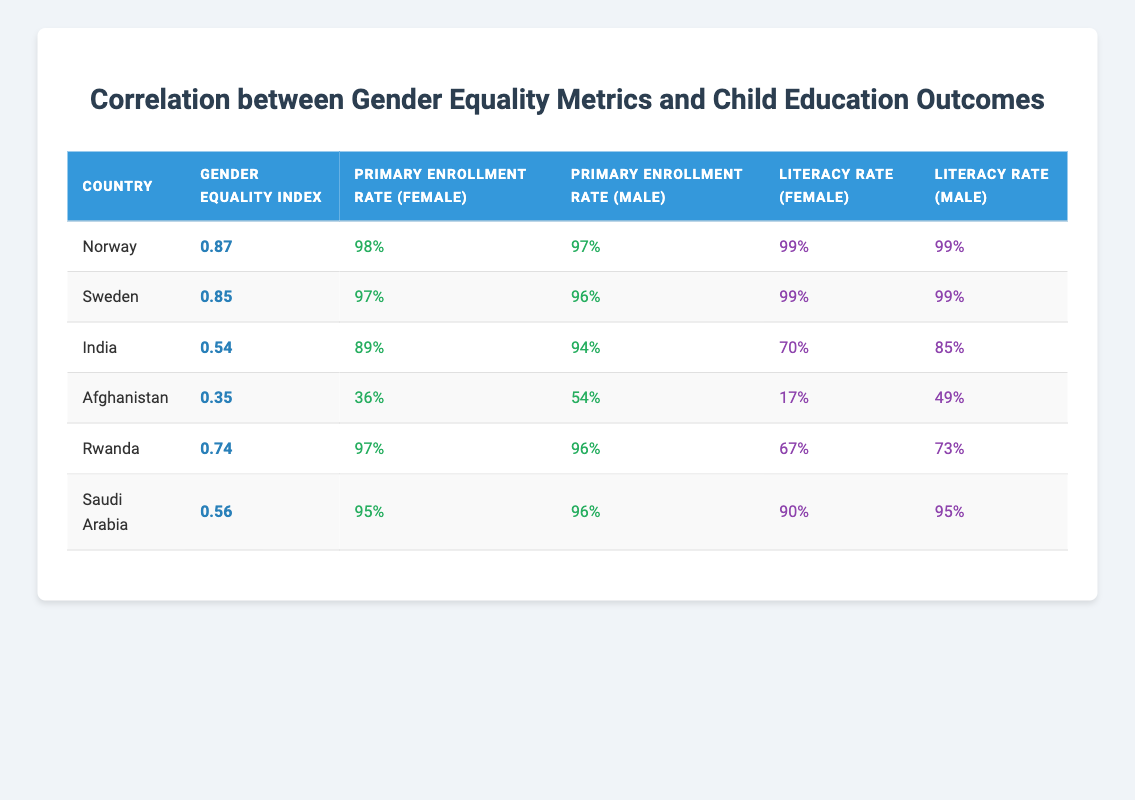What is the Gender Equality Index for India? The table lists India with a Gender Equality Index of 0.54, which can be found in the second column of the India row.
Answer: 0.54 Which country has the highest Primary Enrollment Rate for females? The highest Primary Enrollment Rate for females is 98%, which corresponds to Norway, as shown in the table.
Answer: Norway Is the Literacy Rate for females higher in Sweden or Saudi Arabia? Sweden has a Literacy Rate for females of 99%, while Saudi Arabia has a Literacy Rate for females of 90%. Since 99% is greater than 90%, Sweden has the higher rate.
Answer: Sweden What is the difference between the Primary Enrollment Rates for males in Afghanistan and India? The Primary Enrollment Rate for males in Afghanistan is 54% and for India, it is 94%. The difference is calculated as 94 - 54 = 40.
Answer: 40 True or False: Rwanda has a higher Literacy Rate for females than India. The Literacy Rate for females in Rwanda is 67%, while in India, it is 70%. Since 67% is less than 70%, the statement is false.
Answer: False What is the average Gender Equality Index of the countries listed in the table? To find the average, sum the indices: 0.87 + 0.85 + 0.54 + 0.35 + 0.74 + 0.56 = 3.91. Then, divide by the number of countries (6): 3.91 / 6 ≈ 0.65.
Answer: 0.65 Which country has the lowest Literacy Rate for females, and what is that rate? Referring to the table, Afghanistan has the lowest Literacy Rate for females, listed as 17% in the corresponding row.
Answer: Afghanistan, 17% How many countries have a Primary Enrollment Rate for females of at least 95%? From the table, Norway (98%), Sweden (97%), Rwanda (97%), and Saudi Arabia (95%) all have Primary Enrollment Rates for females of at least 95%. This gives a total of 4 countries.
Answer: 4 Which country has the largest gap between male and female Literacy Rates? The gap is calculated by subtracting the female Literacy Rate from the male Literacy Rate for each country. For Afghanistan, the gap is 49 - 17 = 32; for India, it is 85 - 70 = 15; for Saudi Arabia, it’s 95 - 90 = 5. The largest gap of 32 is in Afghanistan.
Answer: Afghanistan, 32 